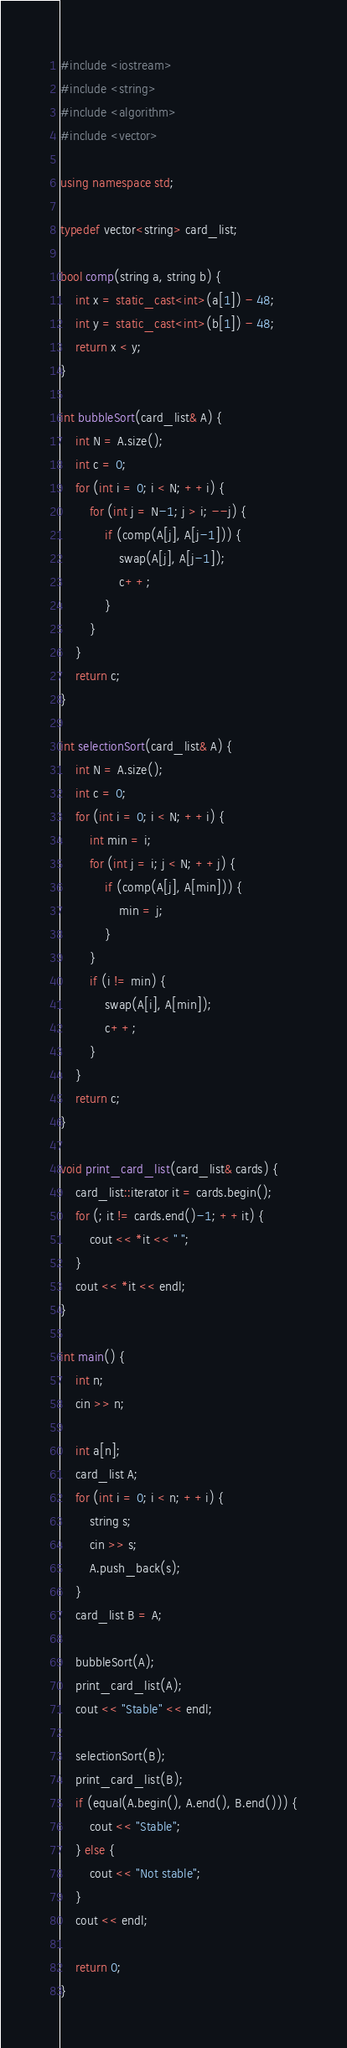<code> <loc_0><loc_0><loc_500><loc_500><_C++_>#include <iostream>
#include <string>
#include <algorithm>
#include <vector>

using namespace std;

typedef vector<string> card_list;

bool comp(string a, string b) {
    int x = static_cast<int>(a[1]) - 48;
    int y = static_cast<int>(b[1]) - 48;
    return x < y;
}

int bubbleSort(card_list& A) {
    int N = A.size();
    int c = 0;
    for (int i = 0; i < N; ++i) {
        for (int j = N-1; j > i; --j) {
            if (comp(A[j], A[j-1])) {
                swap(A[j], A[j-1]);
                c++;
            }
        }
    }
    return c;
}

int selectionSort(card_list& A) {
    int N = A.size();
    int c = 0;
    for (int i = 0; i < N; ++i) {
        int min = i;
        for (int j = i; j < N; ++j) {
            if (comp(A[j], A[min])) {
                min = j;
            }
        }
        if (i != min) {
            swap(A[i], A[min]);
            c++;
        }
    }
    return c;
}

void print_card_list(card_list& cards) {
    card_list::iterator it = cards.begin();
    for (; it != cards.end()-1; ++it) {
        cout << *it << " ";
    }
    cout << *it << endl;
}

int main() {
    int n;
    cin >> n;

    int a[n];
    card_list A;
    for (int i = 0; i < n; ++i) {
        string s;
        cin >> s;
        A.push_back(s);
    }
    card_list B = A;

    bubbleSort(A);
    print_card_list(A);
    cout << "Stable" << endl;

    selectionSort(B);
    print_card_list(B);
    if (equal(A.begin(), A.end(), B.end())) {
        cout << "Stable";
    } else {
        cout << "Not stable";
    }
    cout << endl;

    return 0;
}</code> 